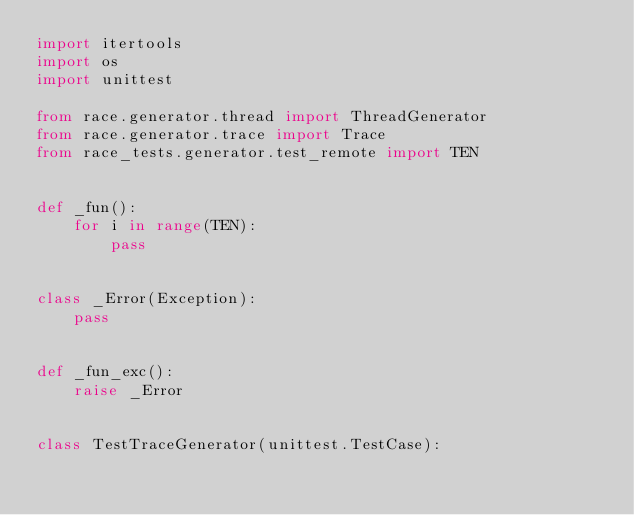<code> <loc_0><loc_0><loc_500><loc_500><_Python_>import itertools
import os
import unittest

from race.generator.thread import ThreadGenerator
from race.generator.trace import Trace
from race_tests.generator.test_remote import TEN


def _fun():
    for i in range(TEN):
        pass


class _Error(Exception):
    pass


def _fun_exc():
    raise _Error


class TestTraceGenerator(unittest.TestCase):</code> 